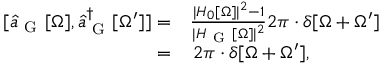Convert formula to latex. <formula><loc_0><loc_0><loc_500><loc_500>\begin{array} { r l } { [ \hat { a } _ { G } [ \Omega ] , \hat { a } _ { G } ^ { \dagger } [ \Omega ^ { \prime } ] ] = } & \frac { | H _ { 0 } [ \Omega ] | ^ { 2 } - 1 } { | H _ { G } [ \Omega ] | ^ { 2 } } 2 \pi \cdot \delta [ \Omega + \Omega ^ { \prime } ] } \\ { = } & \, 2 \pi \cdot \delta [ \Omega + \Omega ^ { \prime } ] , } \end{array}</formula> 